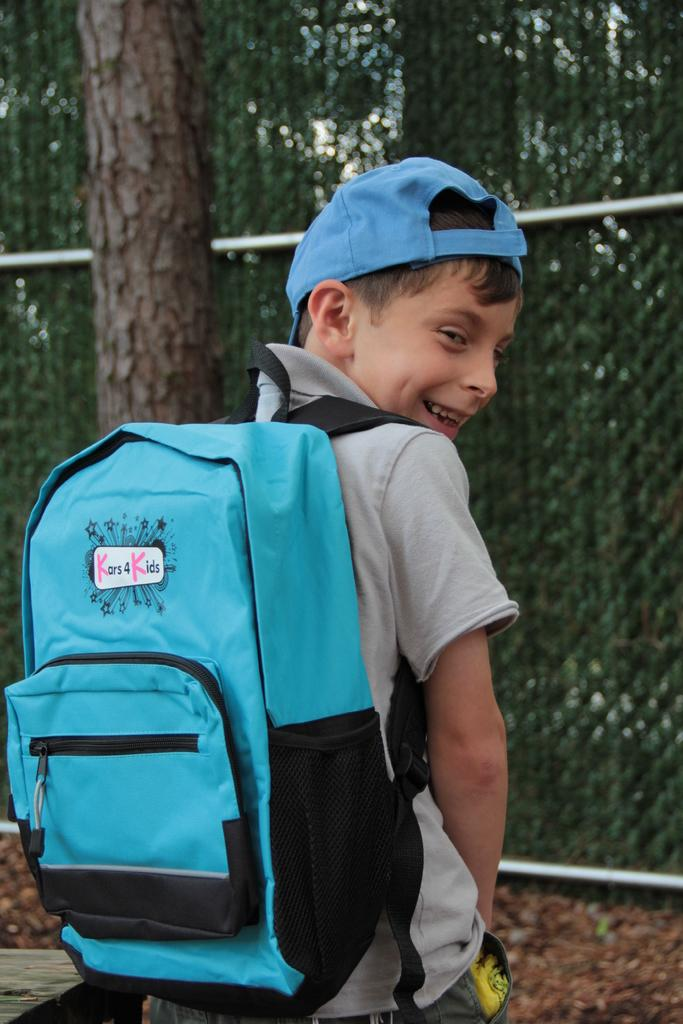<image>
Give a short and clear explanation of the subsequent image. A kid is wearing a blue Kars 4 Kids backpack and smiles looking back,. 